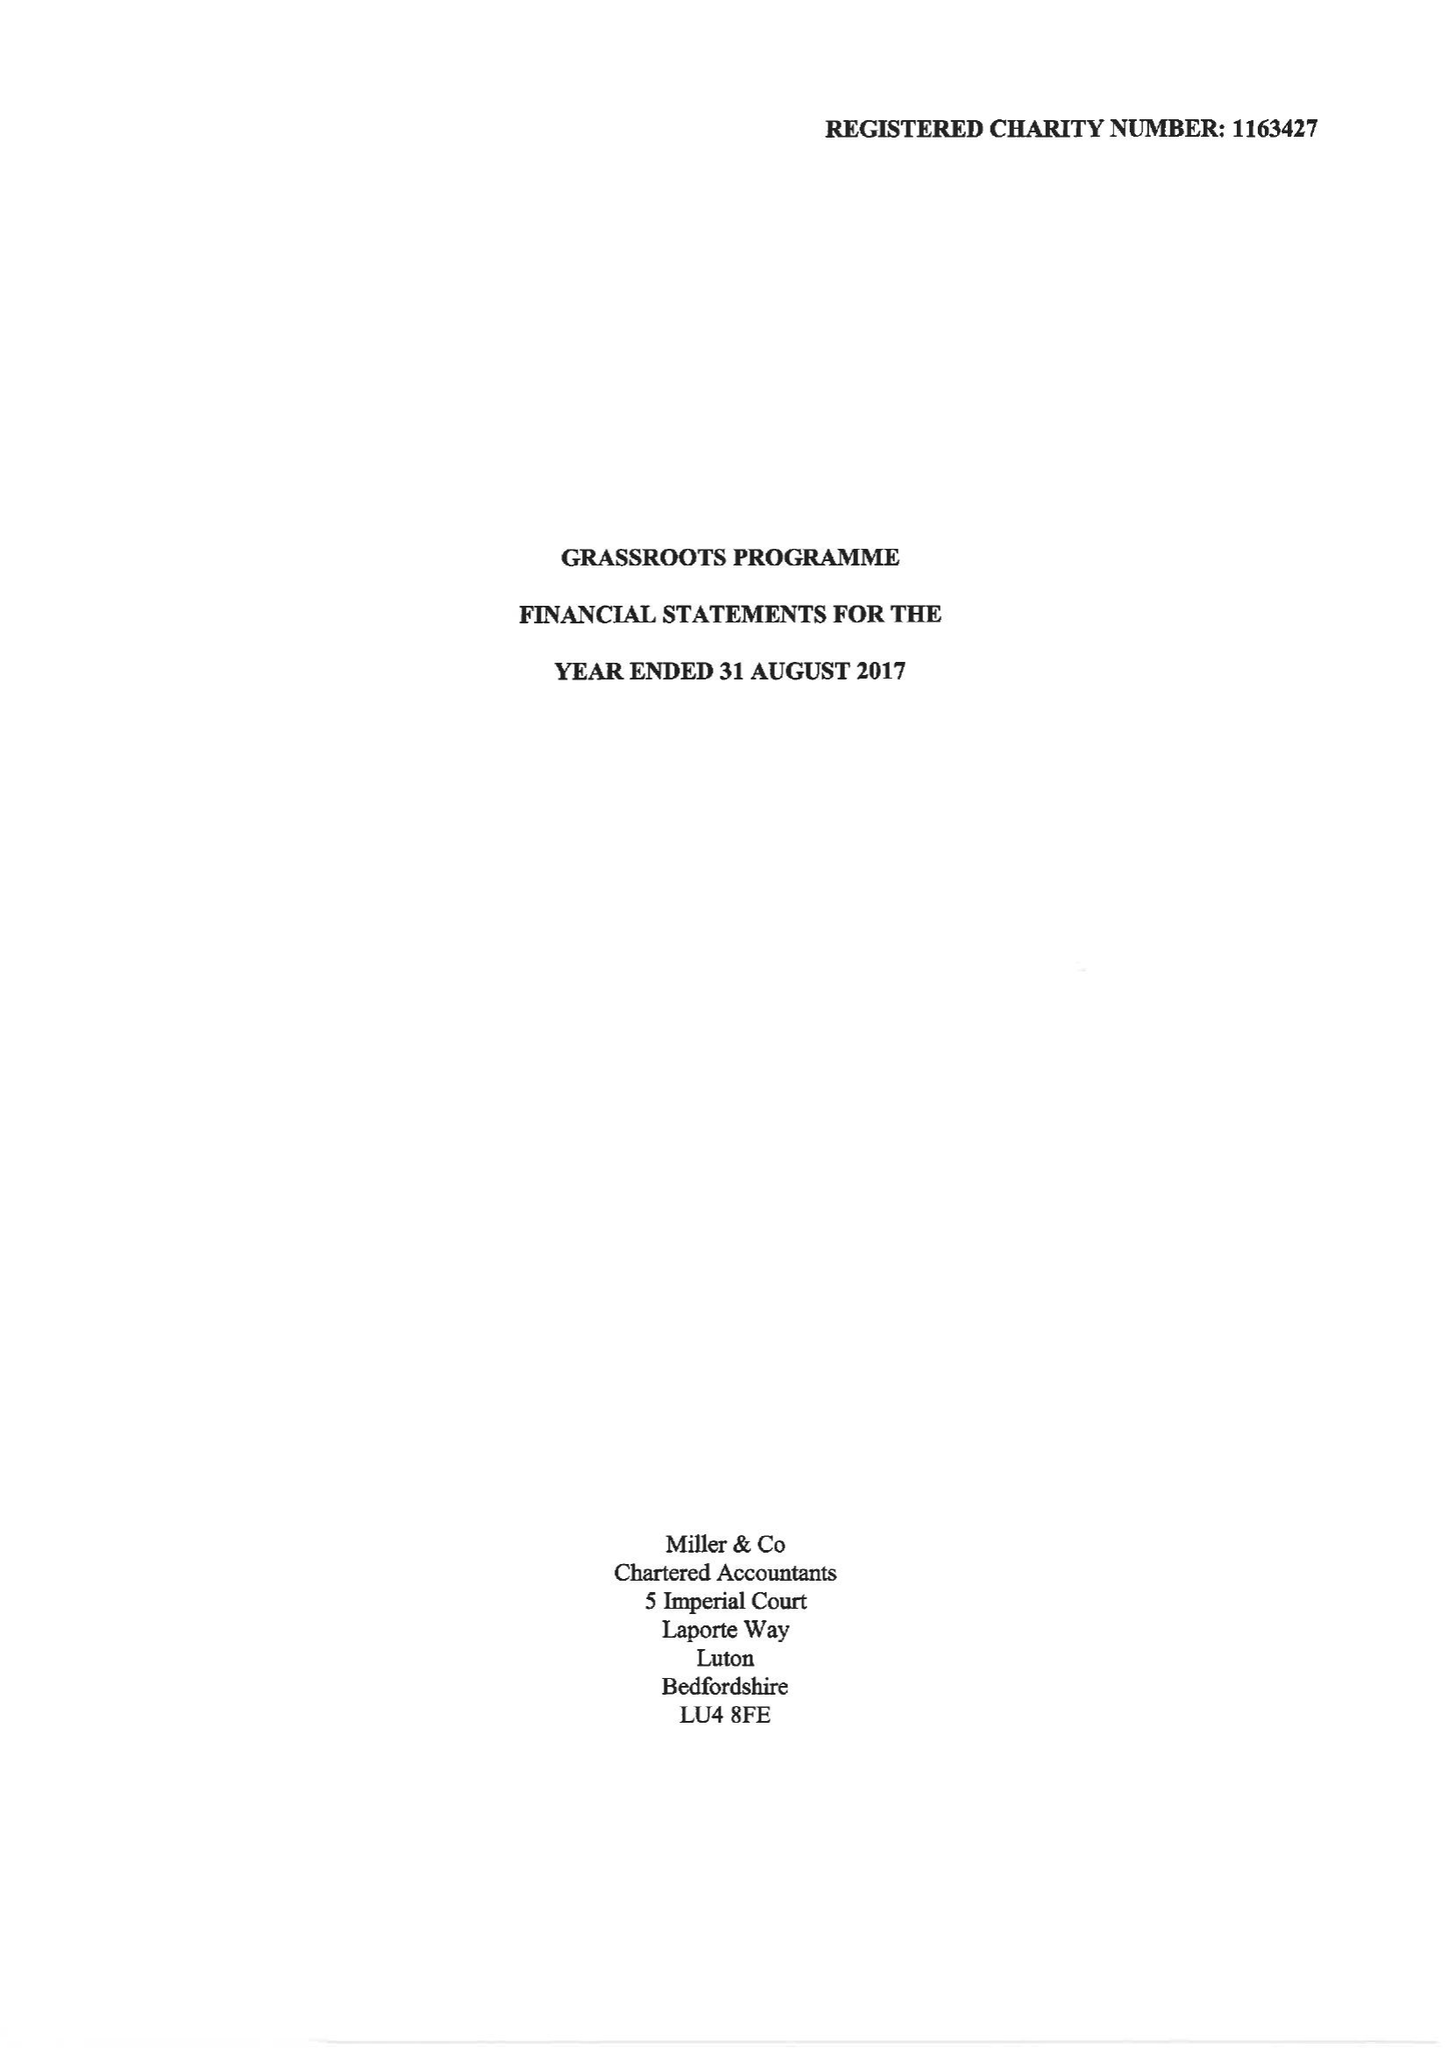What is the value for the address__postcode?
Answer the question using a single word or phrase. LU2 0BW 